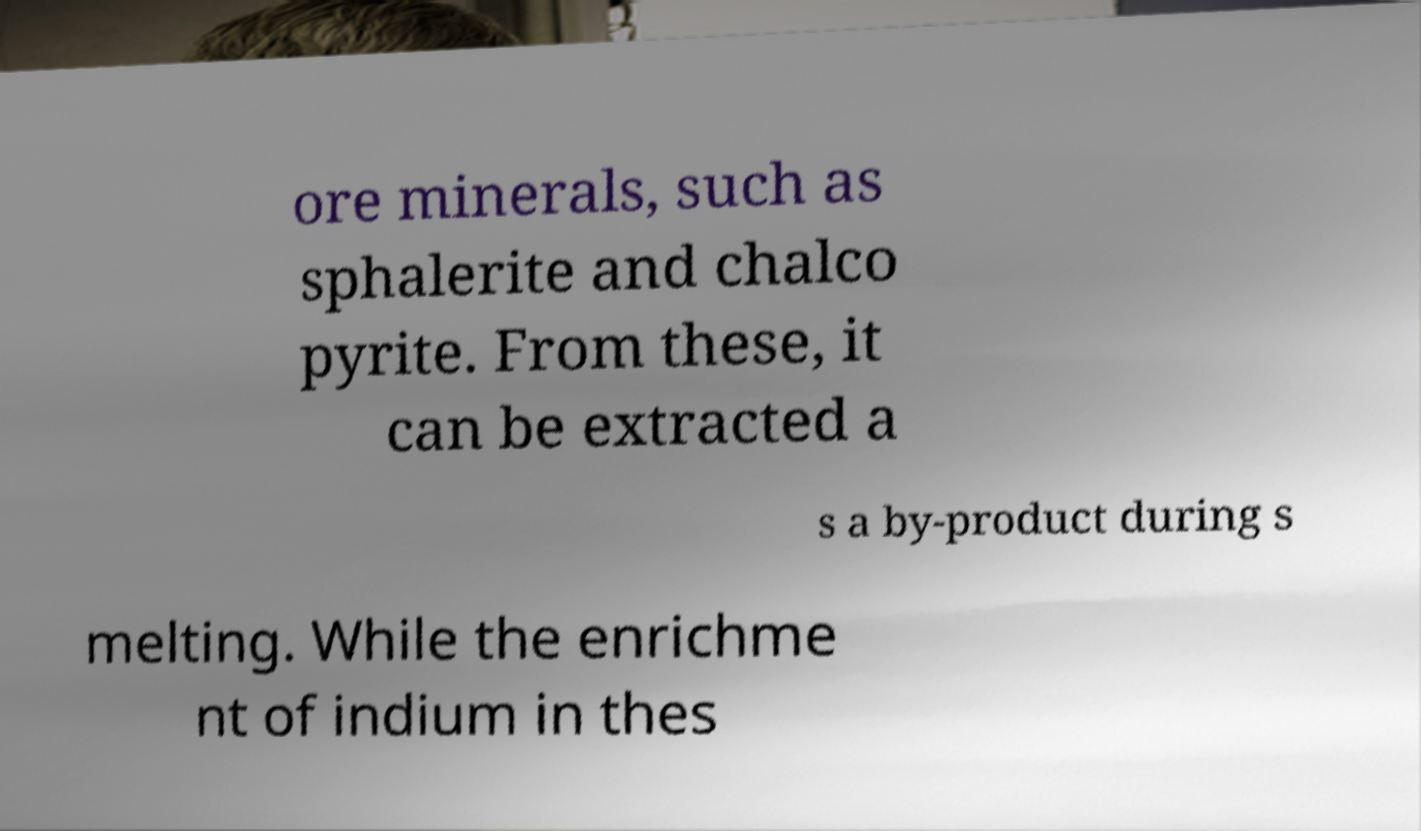Could you extract and type out the text from this image? ore minerals, such as sphalerite and chalco pyrite. From these, it can be extracted a s a by-product during s melting. While the enrichme nt of indium in thes 